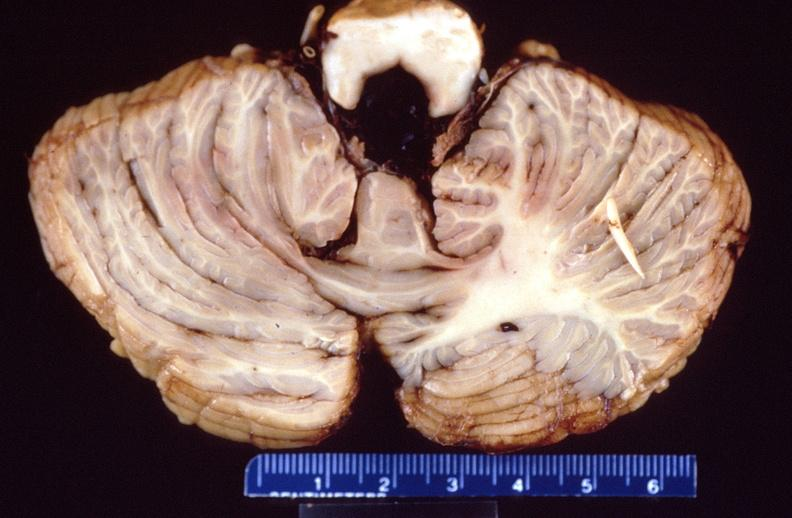s nervous present?
Answer the question using a single word or phrase. Yes 